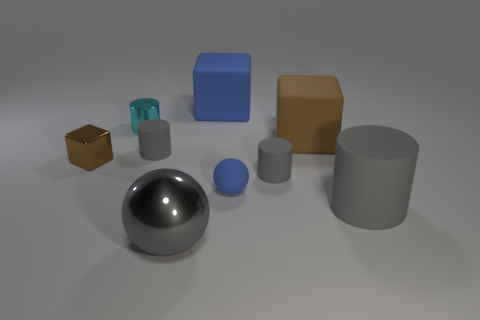There is a metal thing that is the same shape as the large gray matte object; what color is it?
Give a very brief answer. Cyan. Does the brown metallic thing have the same shape as the brown thing to the right of the blue rubber ball?
Give a very brief answer. Yes. Is there a object of the same color as the small block?
Keep it short and to the point. Yes. There is a metal thing that is behind the brown matte object; what size is it?
Ensure brevity in your answer.  Small. What number of other matte objects have the same shape as the large blue object?
Give a very brief answer. 1. What is the material of the gray thing that is both left of the blue cube and in front of the matte sphere?
Provide a succinct answer. Metal. Do the blue ball and the large blue thing have the same material?
Make the answer very short. Yes. What number of cyan rubber cylinders are there?
Provide a succinct answer. 0. There is a sphere right of the big object in front of the big gray object behind the big metallic ball; what is its color?
Offer a terse response. Blue. Do the big rubber cylinder and the big shiny sphere have the same color?
Your answer should be very brief. Yes. 